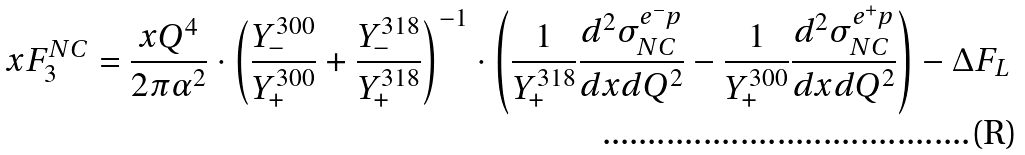Convert formula to latex. <formula><loc_0><loc_0><loc_500><loc_500>x F _ { 3 } ^ { N C } = \frac { x Q ^ { 4 } } { 2 \pi \alpha ^ { 2 } } \cdot \left ( \frac { Y _ { - } ^ { 3 0 0 } } { Y _ { + } ^ { 3 0 0 } } + \frac { Y _ { - } ^ { 3 1 8 } } { Y _ { + } ^ { 3 1 8 } } \right ) ^ { - 1 } \cdot \left ( \frac { 1 } { Y _ { + } ^ { 3 1 8 } } \frac { d ^ { 2 } \sigma _ { N C } ^ { e ^ { - } p } } { d x d Q ^ { 2 } } - \frac { 1 } { Y _ { + } ^ { 3 0 0 } } \frac { d ^ { 2 } \sigma _ { N C } ^ { e ^ { + } p } } { d x d Q ^ { 2 } } \right ) - \Delta F _ { L }</formula> 